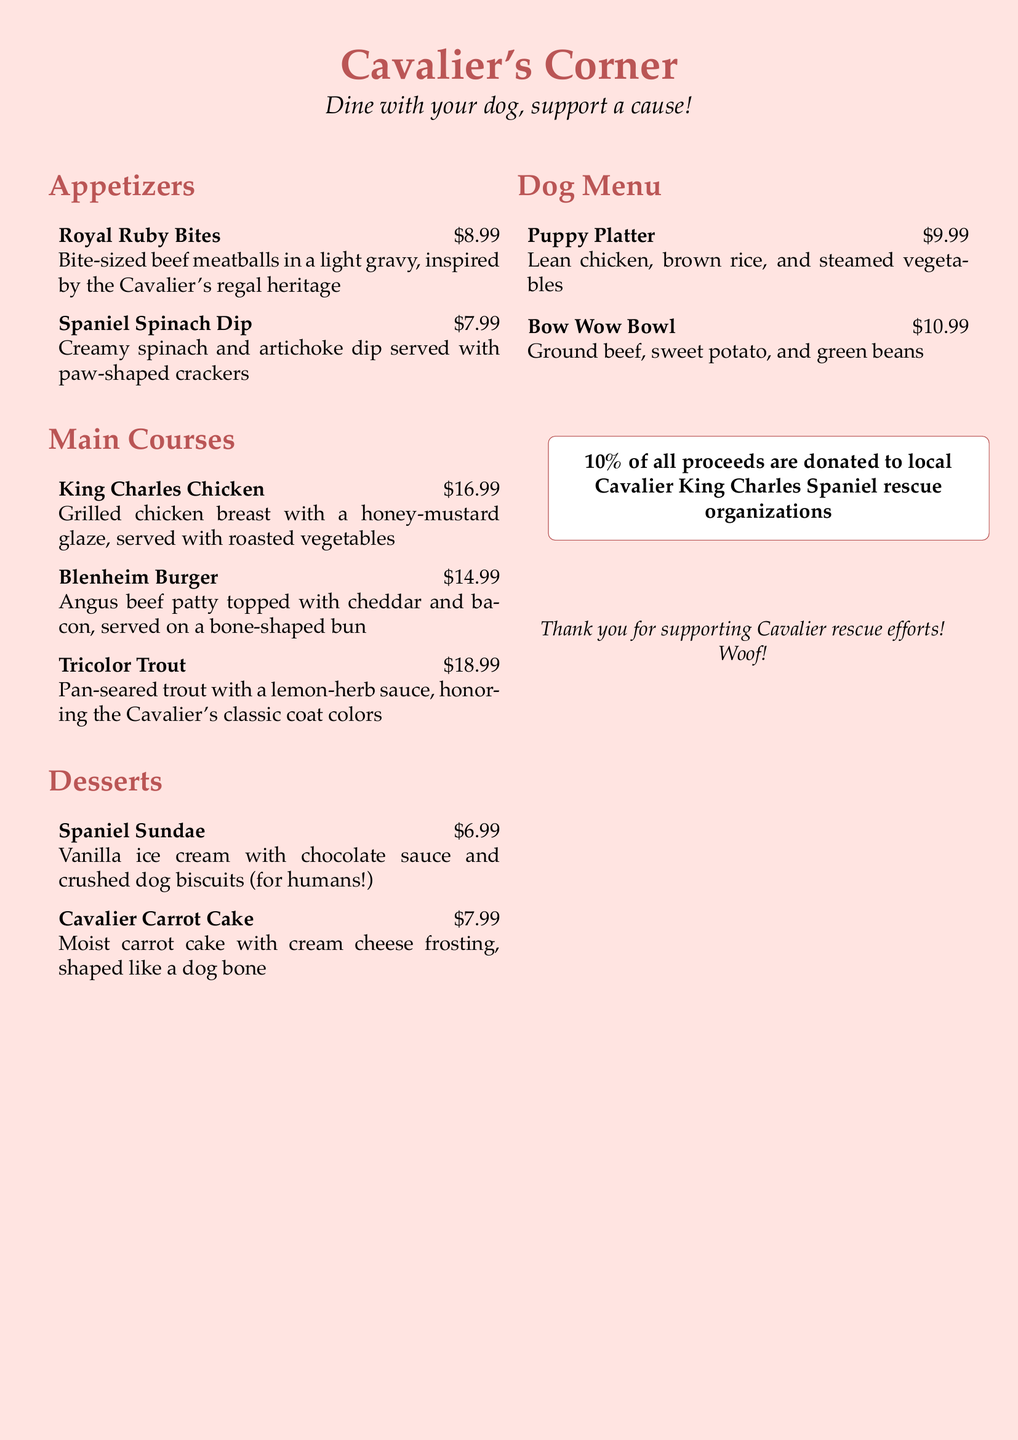What is the name of the restaurant? The restaurant is called "Cavalier's Corner," which is presented prominently at the top of the menu.
Answer: Cavalier's Corner How much is the Royal Ruby Bites? The price for "Royal Ruby Bites" is listed alongside the dish in the appetizers section.
Answer: $8.99 What type of meat is in the Bow Wow Bowl? The Bow Wow Bowl contains ground beef, which is specified in the dog menu section.
Answer: Ground beef What is donated from the proceeds? The document states that a portion of the proceeds is donated to local Cavalier King Charles Spaniel rescue organizations.
Answer: 10% How many main courses are listed? The main courses section lists three distinct dishes, and counting them gives the total.
Answer: 3 What is the price of the Cavalier Carrot Cake? The price is clearly shown next to the dessert in the dessert section.
Answer: $7.99 What unique feature is included in the Blenheim Burger? The Blenheim Burger is served on a bone-shaped bun, which highlights its unique feature.
Answer: Bone-shaped bun Which appetizer is inspired by Cavalier's regal heritage? "Royal Ruby Bites" is specifically mentioned as inspired by the Cavalier's regal heritage in the description.
Answer: Royal Ruby Bites What is the dessert that includes chocolate sauce? The "Spaniel Sundae" is the dessert that includes chocolate sauce based on its description.
Answer: Spaniel Sundae 